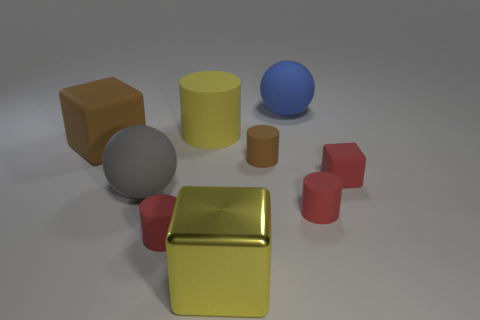Subtract all rubber cubes. How many cubes are left? 1 Subtract all gray spheres. How many spheres are left? 1 Subtract 1 cylinders. How many cylinders are left? 3 Subtract all green cubes. Subtract all cyan cylinders. How many cubes are left? 3 Subtract all red balls. How many yellow cubes are left? 1 Subtract all tiny purple metal spheres. Subtract all large blue matte spheres. How many objects are left? 8 Add 2 large blocks. How many large blocks are left? 4 Add 6 large yellow rubber objects. How many large yellow rubber objects exist? 7 Subtract 1 gray spheres. How many objects are left? 8 Subtract all spheres. How many objects are left? 7 